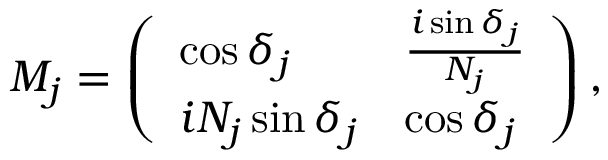Convert formula to latex. <formula><loc_0><loc_0><loc_500><loc_500>M _ { j } = \left ( \begin{array} { l l } { \cos { \delta _ { j } } } & { \frac { i \sin { \delta _ { j } } } { N _ { j } } } \\ { i N _ { j } \sin { \delta _ { j } } } & { \cos { \delta _ { j } } } \end{array} \right ) ,</formula> 